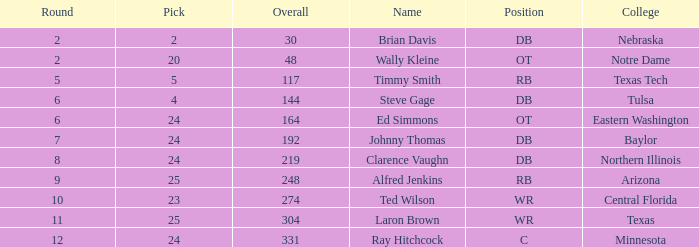What top round has a pick smaller than 2? None. 